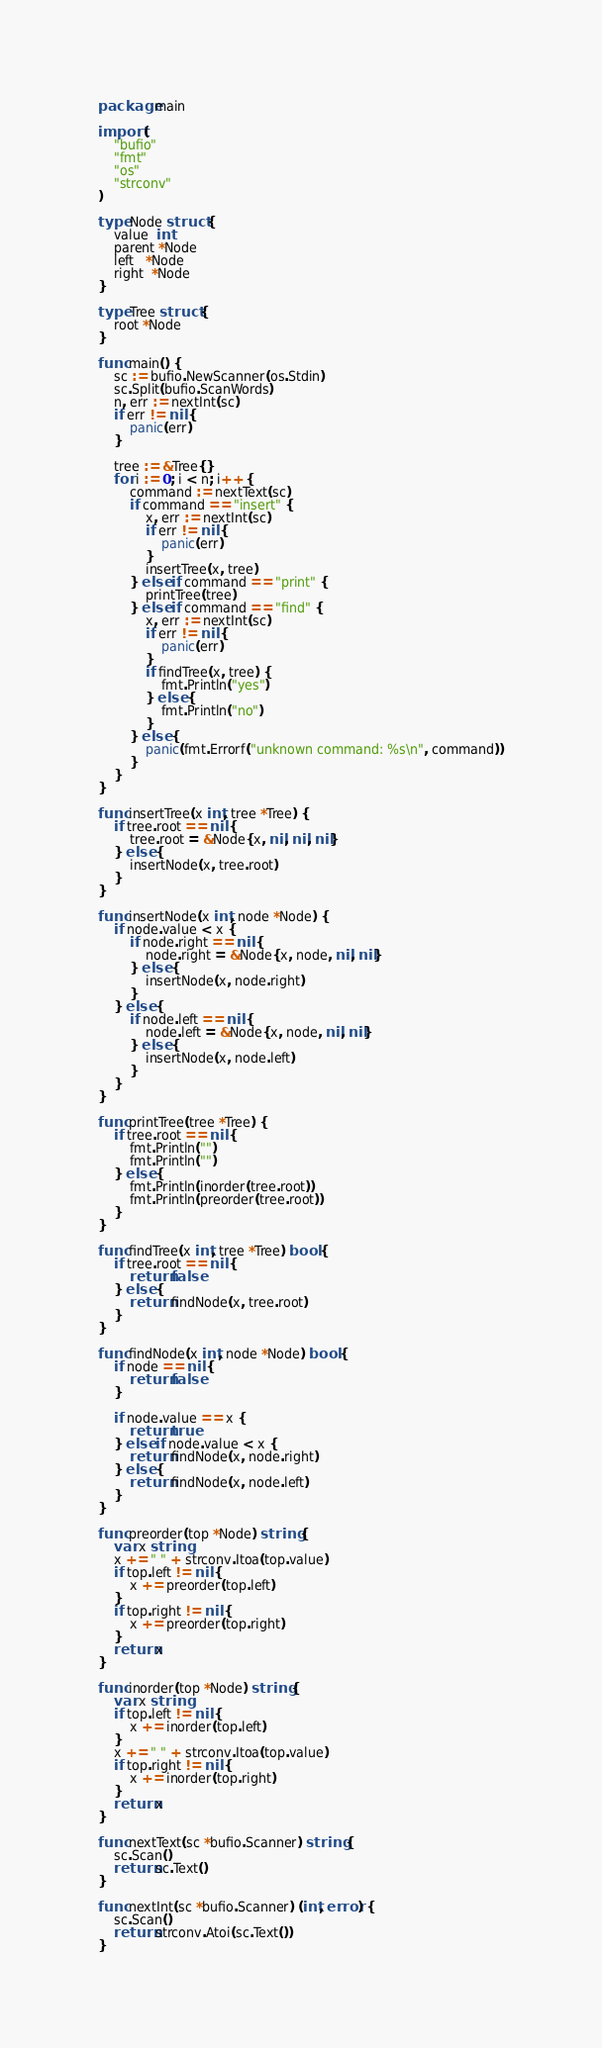Convert code to text. <code><loc_0><loc_0><loc_500><loc_500><_Go_>package main

import (
	"bufio"
	"fmt"
	"os"
	"strconv"
)

type Node struct {
	value  int
	parent *Node
	left   *Node
	right  *Node
}

type Tree struct {
	root *Node
}

func main() {
	sc := bufio.NewScanner(os.Stdin)
	sc.Split(bufio.ScanWords)
	n, err := nextInt(sc)
	if err != nil {
		panic(err)
	}

	tree := &Tree{}
	for i := 0; i < n; i++ {
		command := nextText(sc)
		if command == "insert" {
			x, err := nextInt(sc)
			if err != nil {
				panic(err)
			}
			insertTree(x, tree)
		} else if command == "print" {
			printTree(tree)
		} else if command == "find" {
			x, err := nextInt(sc)
			if err != nil {
				panic(err)
			}
			if findTree(x, tree) {
				fmt.Println("yes")
			} else {
				fmt.Println("no")
			}
		} else {
			panic(fmt.Errorf("unknown command: %s\n", command))
		}
	}
}

func insertTree(x int, tree *Tree) {
	if tree.root == nil {
		tree.root = &Node{x, nil, nil, nil}
	} else {
		insertNode(x, tree.root)
	}
}

func insertNode(x int, node *Node) {
	if node.value < x {
		if node.right == nil {
			node.right = &Node{x, node, nil, nil}
		} else {
			insertNode(x, node.right)
		}
	} else {
		if node.left == nil {
			node.left = &Node{x, node, nil, nil}
		} else {
			insertNode(x, node.left)
		}
	}
}

func printTree(tree *Tree) {
	if tree.root == nil {
		fmt.Println("")
		fmt.Println("")
	} else {
		fmt.Println(inorder(tree.root))
		fmt.Println(preorder(tree.root))
	}
}

func findTree(x int, tree *Tree) bool {
	if tree.root == nil {
		return false
	} else {
		return findNode(x, tree.root)
	}
}

func findNode(x int, node *Node) bool {
	if node == nil {
		return false
	}

	if node.value == x {
		return true
	} else if node.value < x {
		return findNode(x, node.right)
	} else {
		return findNode(x, node.left)
	}
}

func preorder(top *Node) string {
	var x string
	x += " " + strconv.Itoa(top.value)
	if top.left != nil {
		x += preorder(top.left)
	}
	if top.right != nil {
		x += preorder(top.right)
	}
	return x
}

func inorder(top *Node) string {
	var x string
	if top.left != nil {
		x += inorder(top.left)
	}
	x += " " + strconv.Itoa(top.value)
	if top.right != nil {
		x += inorder(top.right)
	}
	return x
}

func nextText(sc *bufio.Scanner) string {
	sc.Scan()
	return sc.Text()
}

func nextInt(sc *bufio.Scanner) (int, error) {
	sc.Scan()
	return strconv.Atoi(sc.Text())
}

</code> 